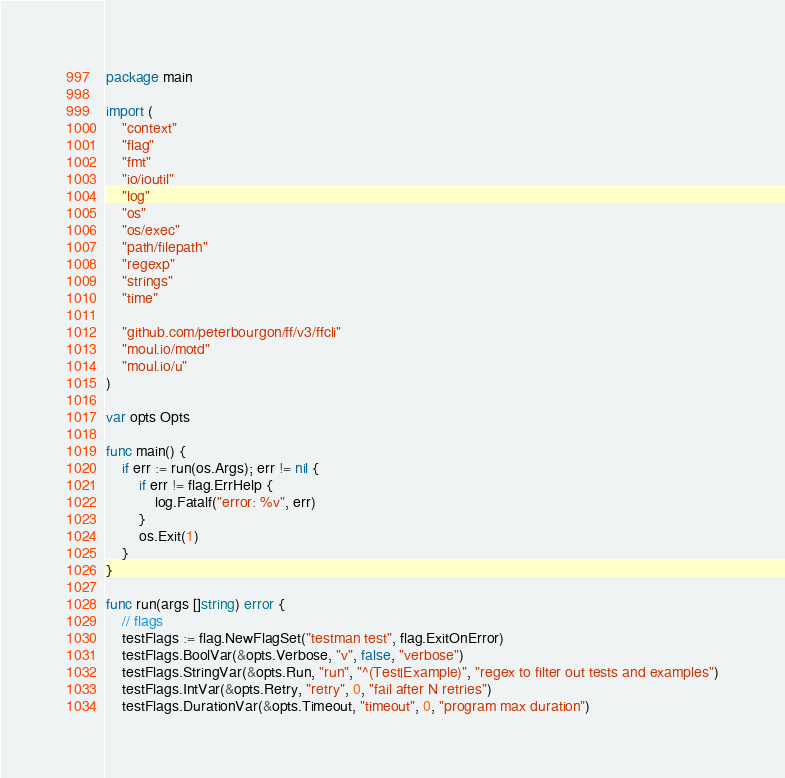<code> <loc_0><loc_0><loc_500><loc_500><_Go_>package main

import (
	"context"
	"flag"
	"fmt"
	"io/ioutil"
	"log"
	"os"
	"os/exec"
	"path/filepath"
	"regexp"
	"strings"
	"time"

	"github.com/peterbourgon/ff/v3/ffcli"
	"moul.io/motd"
	"moul.io/u"
)

var opts Opts

func main() {
	if err := run(os.Args); err != nil {
		if err != flag.ErrHelp {
			log.Fatalf("error: %v", err)
		}
		os.Exit(1)
	}
}

func run(args []string) error {
	// flags
	testFlags := flag.NewFlagSet("testman test", flag.ExitOnError)
	testFlags.BoolVar(&opts.Verbose, "v", false, "verbose")
	testFlags.StringVar(&opts.Run, "run", "^(Test|Example)", "regex to filter out tests and examples")
	testFlags.IntVar(&opts.Retry, "retry", 0, "fail after N retries")
	testFlags.DurationVar(&opts.Timeout, "timeout", 0, "program max duration")</code> 